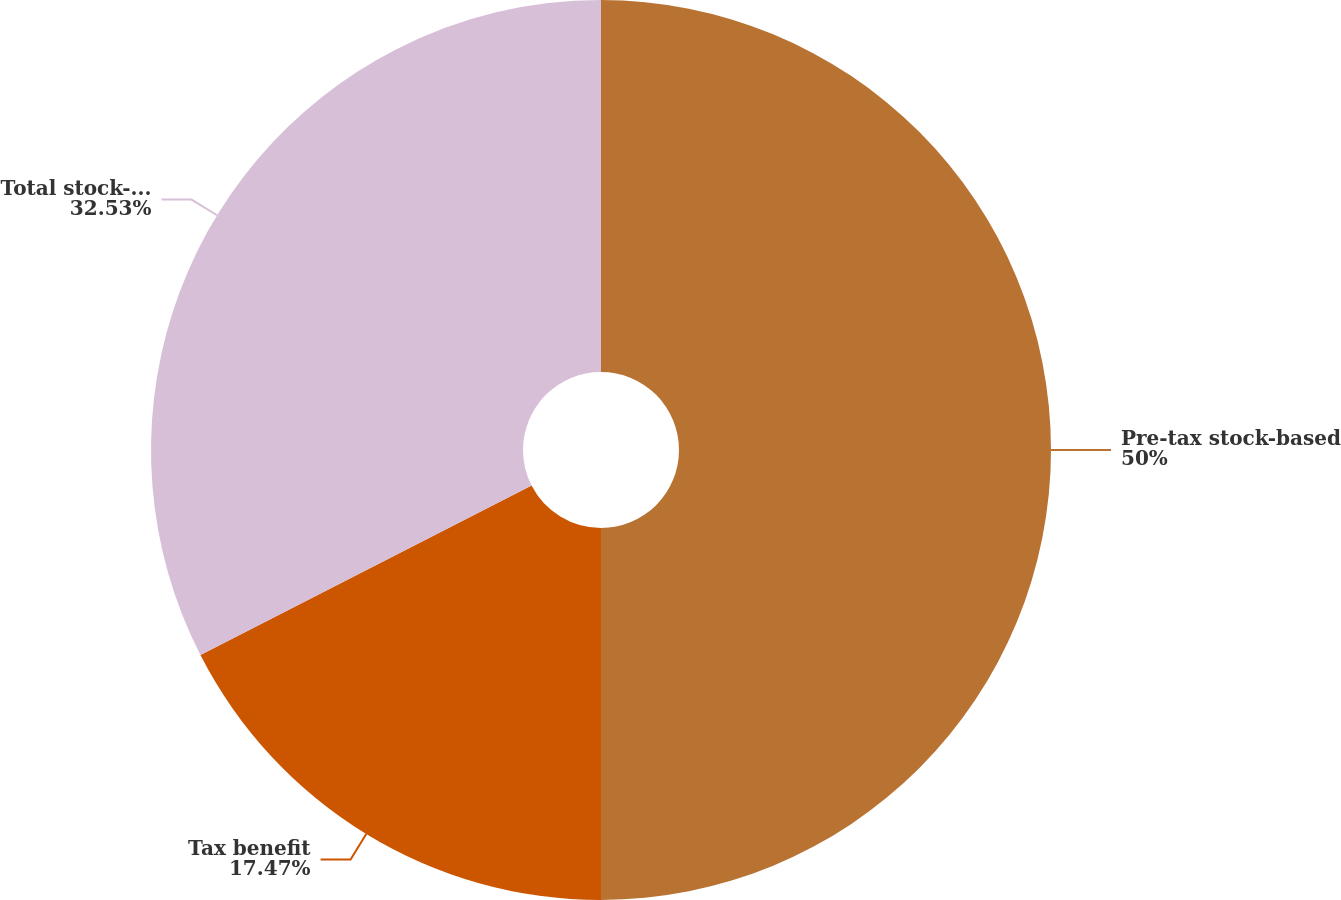Convert chart. <chart><loc_0><loc_0><loc_500><loc_500><pie_chart><fcel>Pre-tax stock-based<fcel>Tax benefit<fcel>Total stock-based compensation<nl><fcel>50.0%<fcel>17.47%<fcel>32.53%<nl></chart> 